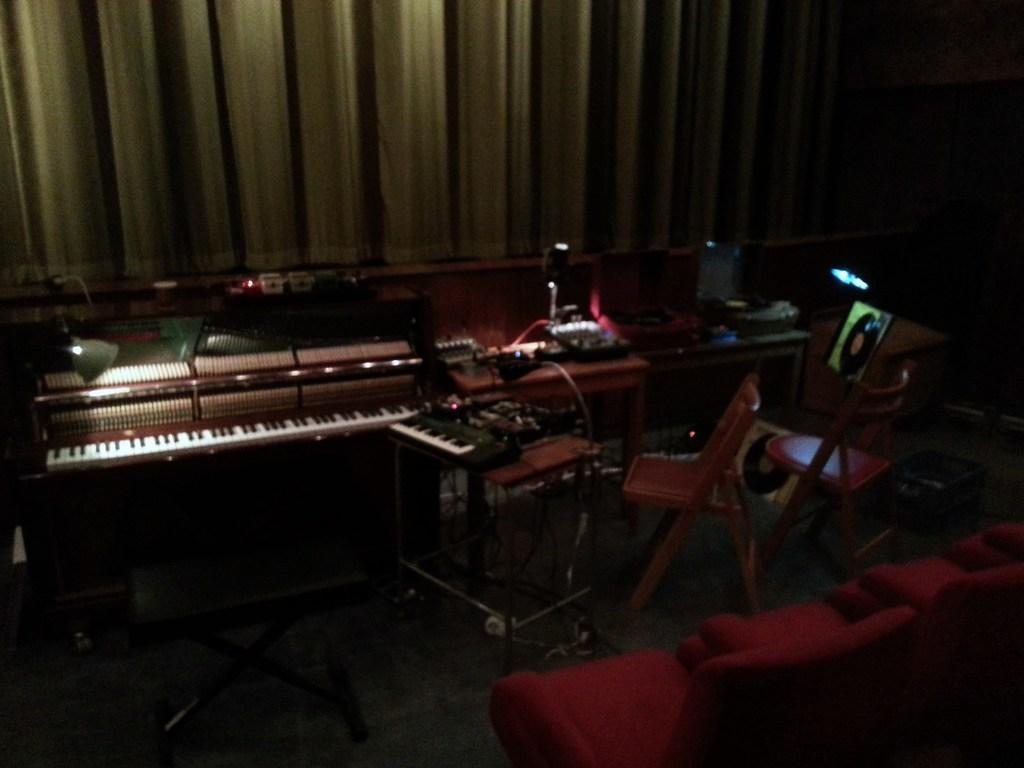Could you give a brief overview of what you see in this image? In this picture we can see a table and on table we have a piano beside to this table there are two chairs and in front of this on table we have wires, devices, lamp, piano keyboard and in the background we can see curtains, light, chairs. 